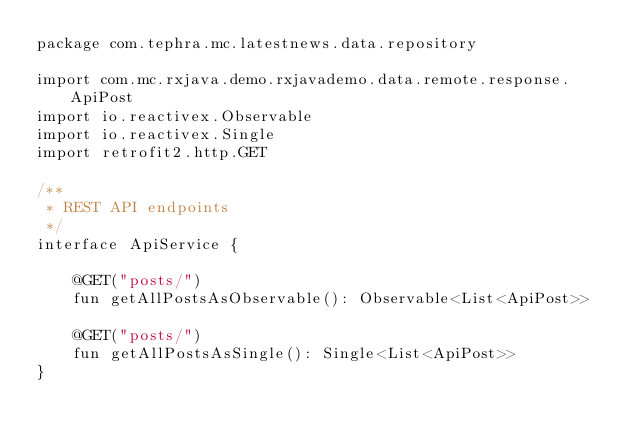<code> <loc_0><loc_0><loc_500><loc_500><_Kotlin_>package com.tephra.mc.latestnews.data.repository

import com.mc.rxjava.demo.rxjavademo.data.remote.response.ApiPost
import io.reactivex.Observable
import io.reactivex.Single
import retrofit2.http.GET

/**
 * REST API endpoints
 */
interface ApiService {

    @GET("posts/")
    fun getAllPostsAsObservable(): Observable<List<ApiPost>>

    @GET("posts/")
    fun getAllPostsAsSingle(): Single<List<ApiPost>>
}</code> 